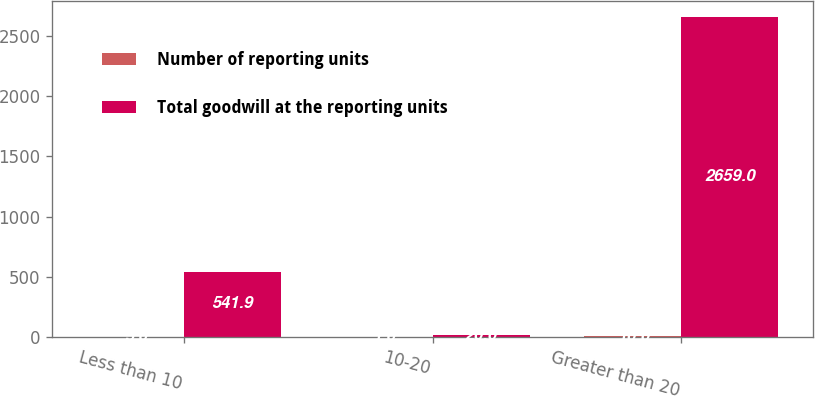Convert chart to OTSL. <chart><loc_0><loc_0><loc_500><loc_500><stacked_bar_chart><ecel><fcel>Less than 10<fcel>10-20<fcel>Greater than 20<nl><fcel>Number of reporting units<fcel>5<fcel>1<fcel>10<nl><fcel>Total goodwill at the reporting units<fcel>541.9<fcel>20<fcel>2659<nl></chart> 